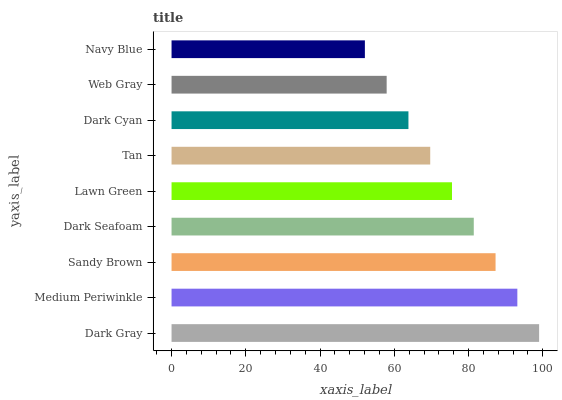Is Navy Blue the minimum?
Answer yes or no. Yes. Is Dark Gray the maximum?
Answer yes or no. Yes. Is Medium Periwinkle the minimum?
Answer yes or no. No. Is Medium Periwinkle the maximum?
Answer yes or no. No. Is Dark Gray greater than Medium Periwinkle?
Answer yes or no. Yes. Is Medium Periwinkle less than Dark Gray?
Answer yes or no. Yes. Is Medium Periwinkle greater than Dark Gray?
Answer yes or no. No. Is Dark Gray less than Medium Periwinkle?
Answer yes or no. No. Is Lawn Green the high median?
Answer yes or no. Yes. Is Lawn Green the low median?
Answer yes or no. Yes. Is Dark Cyan the high median?
Answer yes or no. No. Is Dark Seafoam the low median?
Answer yes or no. No. 